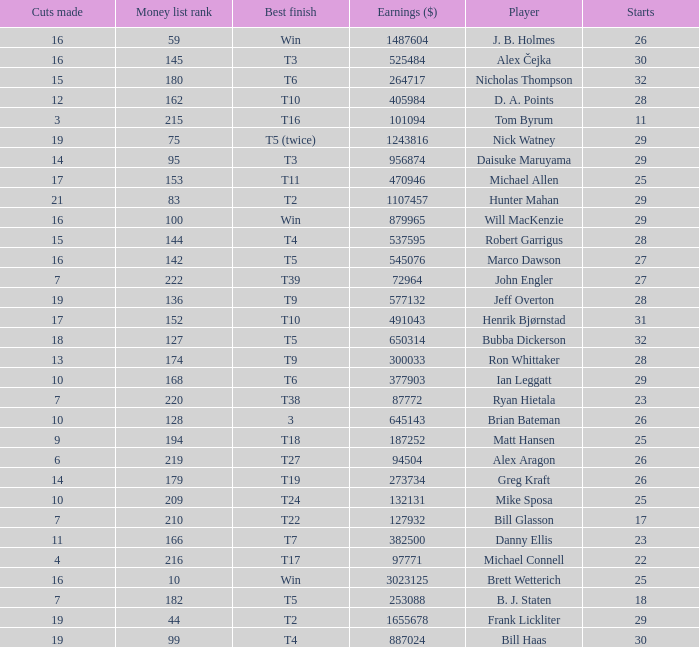What is the minimum number of starts for the players having a best finish of T18? 25.0. 